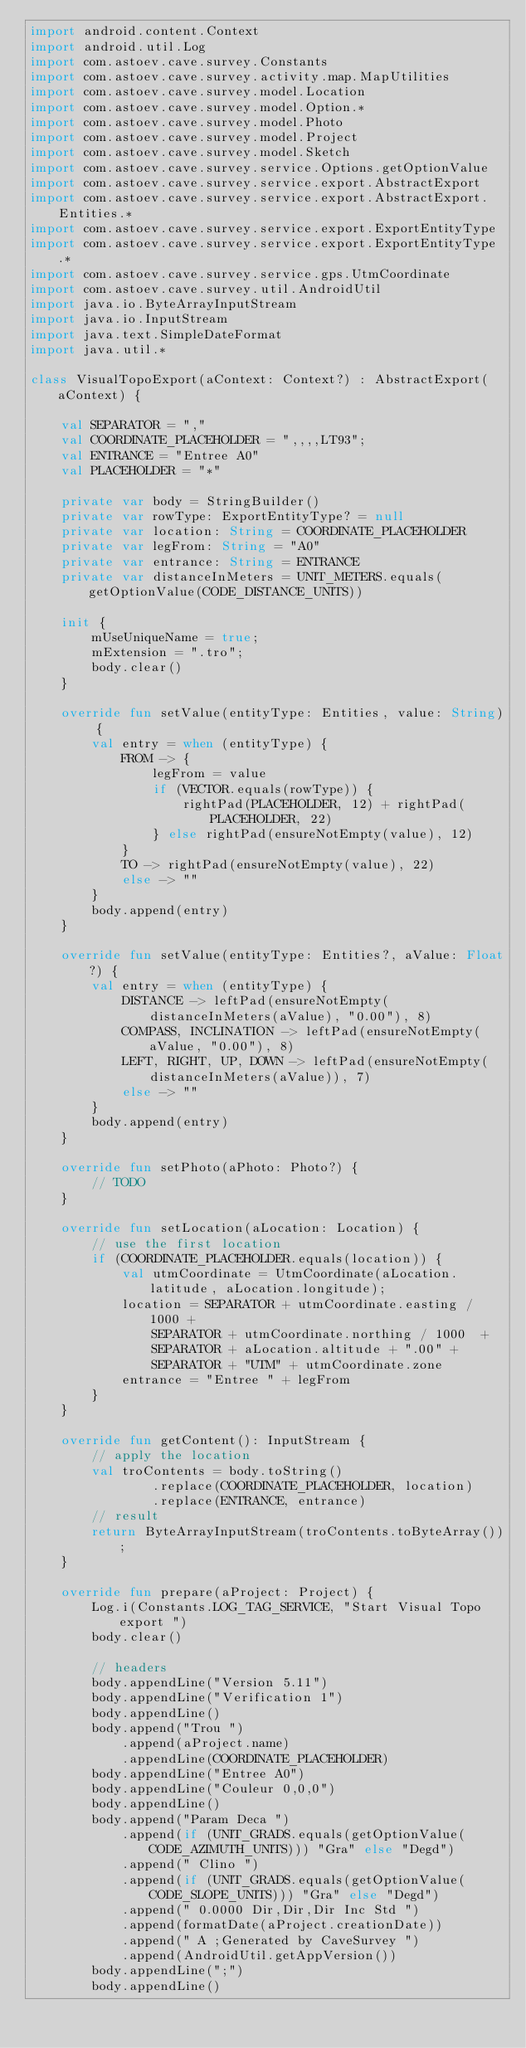<code> <loc_0><loc_0><loc_500><loc_500><_Kotlin_>import android.content.Context
import android.util.Log
import com.astoev.cave.survey.Constants
import com.astoev.cave.survey.activity.map.MapUtilities
import com.astoev.cave.survey.model.Location
import com.astoev.cave.survey.model.Option.*
import com.astoev.cave.survey.model.Photo
import com.astoev.cave.survey.model.Project
import com.astoev.cave.survey.model.Sketch
import com.astoev.cave.survey.service.Options.getOptionValue
import com.astoev.cave.survey.service.export.AbstractExport
import com.astoev.cave.survey.service.export.AbstractExport.Entities.*
import com.astoev.cave.survey.service.export.ExportEntityType
import com.astoev.cave.survey.service.export.ExportEntityType.*
import com.astoev.cave.survey.service.gps.UtmCoordinate
import com.astoev.cave.survey.util.AndroidUtil
import java.io.ByteArrayInputStream
import java.io.InputStream
import java.text.SimpleDateFormat
import java.util.*

class VisualTopoExport(aContext: Context?) : AbstractExport(aContext) {

    val SEPARATOR = ","
    val COORDINATE_PLACEHOLDER = ",,,,LT93";
    val ENTRANCE = "Entree A0"
    val PLACEHOLDER = "*"

    private var body = StringBuilder()
    private var rowType: ExportEntityType? = null
    private var location: String = COORDINATE_PLACEHOLDER
    private var legFrom: String = "A0"
    private var entrance: String = ENTRANCE
    private var distanceInMeters = UNIT_METERS.equals(getOptionValue(CODE_DISTANCE_UNITS))

    init {
        mUseUniqueName = true;
        mExtension = ".tro";
        body.clear()
    }

    override fun setValue(entityType: Entities, value: String) {
        val entry = when (entityType) {
            FROM -> {
                legFrom = value
                if (VECTOR.equals(rowType)) {
                    rightPad(PLACEHOLDER, 12) + rightPad(PLACEHOLDER, 22)
                } else rightPad(ensureNotEmpty(value), 12)
            }
            TO -> rightPad(ensureNotEmpty(value), 22)
            else -> ""
        }
        body.append(entry)
    }

    override fun setValue(entityType: Entities?, aValue: Float?) {
        val entry = when (entityType) {
            DISTANCE -> leftPad(ensureNotEmpty(distanceInMeters(aValue), "0.00"), 8)
            COMPASS, INCLINATION -> leftPad(ensureNotEmpty(aValue, "0.00"), 8)
            LEFT, RIGHT, UP, DOWN -> leftPad(ensureNotEmpty(distanceInMeters(aValue)), 7)
            else -> ""
        }
        body.append(entry)
    }

    override fun setPhoto(aPhoto: Photo?) {
        // TODO
    }

    override fun setLocation(aLocation: Location) {
        // use the first location
        if (COORDINATE_PLACEHOLDER.equals(location)) {
            val utmCoordinate = UtmCoordinate(aLocation.latitude, aLocation.longitude);
            location = SEPARATOR + utmCoordinate.easting / 1000 +
                SEPARATOR + utmCoordinate.northing / 1000  +
                SEPARATOR + aLocation.altitude + ".00" +
                SEPARATOR + "UTM" + utmCoordinate.zone
            entrance = "Entree " + legFrom
        }
    }

    override fun getContent(): InputStream {
        // apply the location
        val troContents = body.toString()
                .replace(COORDINATE_PLACEHOLDER, location)
                .replace(ENTRANCE, entrance)
        // result
        return ByteArrayInputStream(troContents.toByteArray());
    }

    override fun prepare(aProject: Project) {
        Log.i(Constants.LOG_TAG_SERVICE, "Start Visual Topo export ")
        body.clear()

        // headers
        body.appendLine("Version 5.11")
        body.appendLine("Verification 1")
        body.appendLine()
        body.append("Trou ")
            .append(aProject.name)
            .appendLine(COORDINATE_PLACEHOLDER)
        body.appendLine("Entree A0")
        body.appendLine("Couleur 0,0,0")
        body.appendLine()
        body.append("Param Deca ")
            .append(if (UNIT_GRADS.equals(getOptionValue(CODE_AZIMUTH_UNITS))) "Gra" else "Degd")
            .append(" Clino ")
            .append(if (UNIT_GRADS.equals(getOptionValue(CODE_SLOPE_UNITS))) "Gra" else "Degd")
            .append(" 0.0000 Dir,Dir,Dir Inc Std ")
            .append(formatDate(aProject.creationDate))
            .append(" A ;Generated by CaveSurvey ")
            .append(AndroidUtil.getAppVersion())
        body.appendLine(";")
        body.appendLine()</code> 